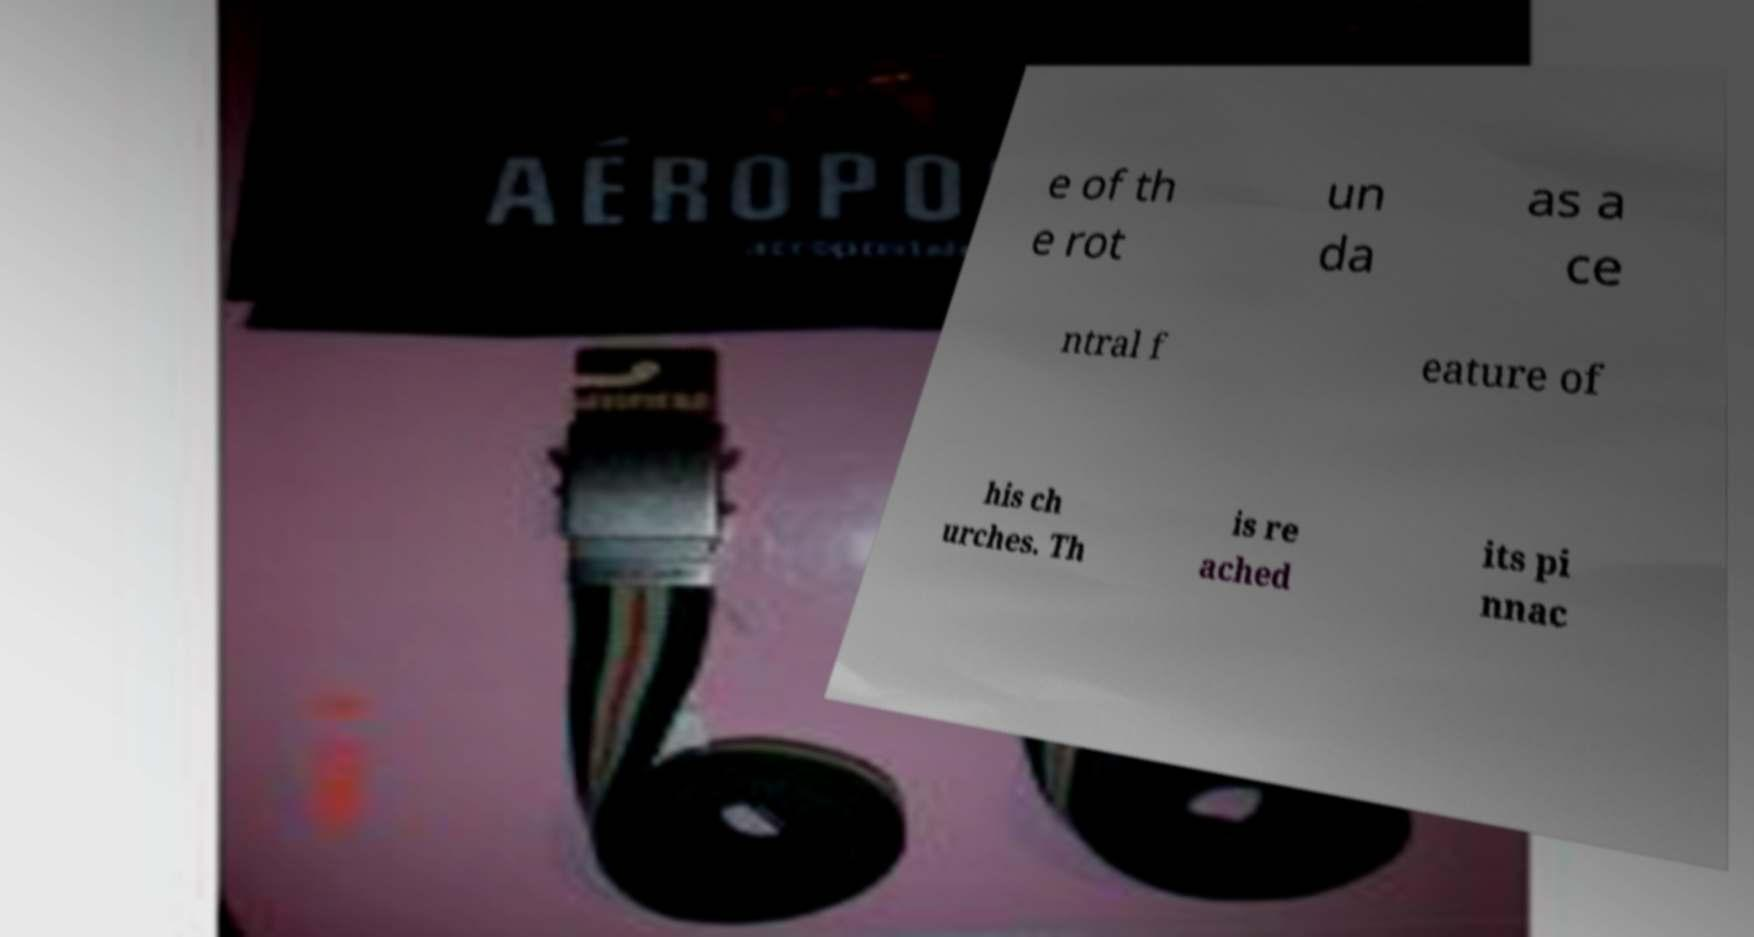Could you assist in decoding the text presented in this image and type it out clearly? e of th e rot un da as a ce ntral f eature of his ch urches. Th is re ached its pi nnac 